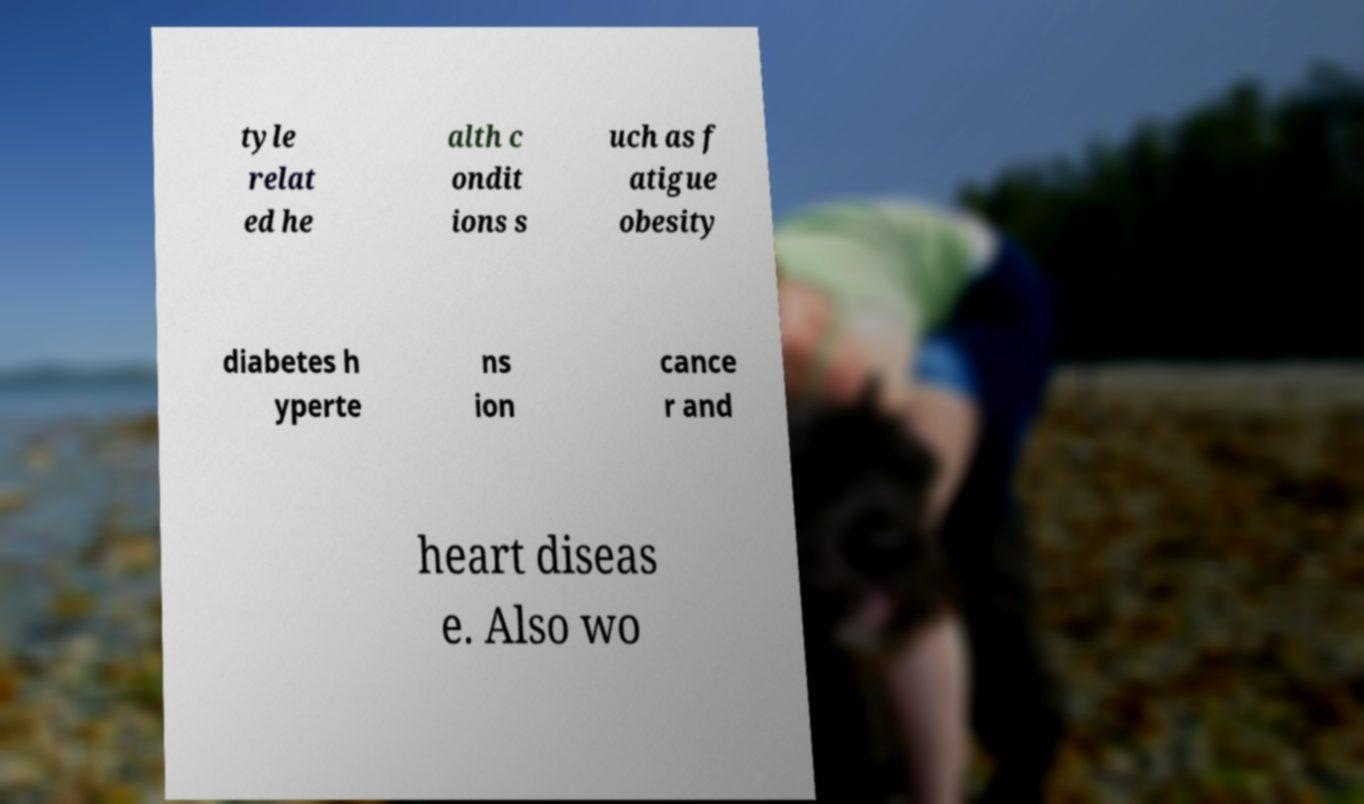There's text embedded in this image that I need extracted. Can you transcribe it verbatim? tyle relat ed he alth c ondit ions s uch as f atigue obesity diabetes h yperte ns ion cance r and heart diseas e. Also wo 